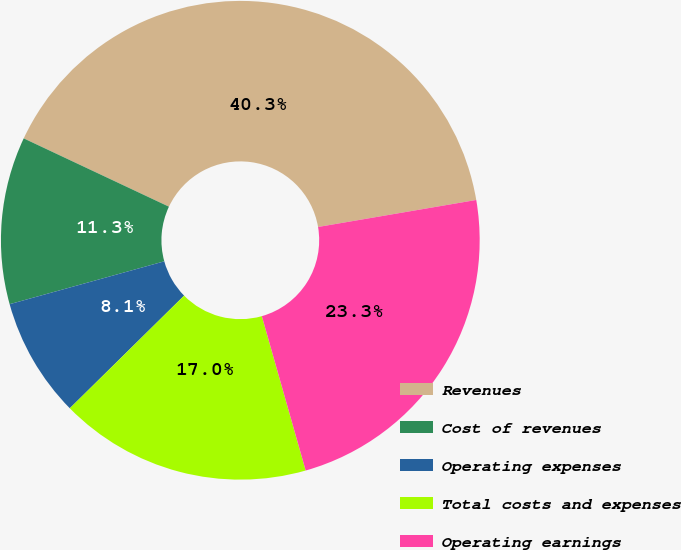<chart> <loc_0><loc_0><loc_500><loc_500><pie_chart><fcel>Revenues<fcel>Cost of revenues<fcel>Operating expenses<fcel>Total costs and expenses<fcel>Operating earnings<nl><fcel>40.31%<fcel>11.3%<fcel>8.08%<fcel>17.02%<fcel>23.29%<nl></chart> 